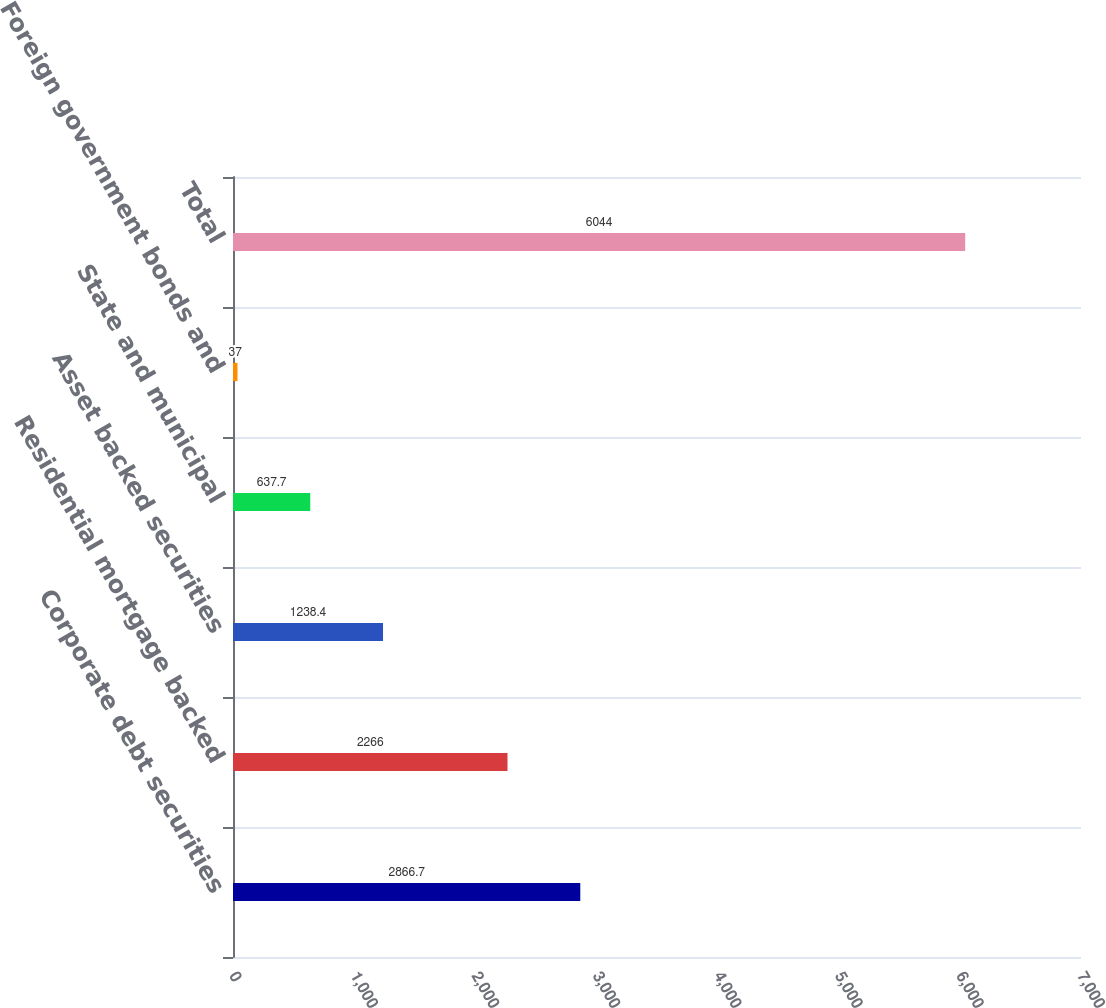Convert chart. <chart><loc_0><loc_0><loc_500><loc_500><bar_chart><fcel>Corporate debt securities<fcel>Residential mortgage backed<fcel>Asset backed securities<fcel>State and municipal<fcel>Foreign government bonds and<fcel>Total<nl><fcel>2866.7<fcel>2266<fcel>1238.4<fcel>637.7<fcel>37<fcel>6044<nl></chart> 